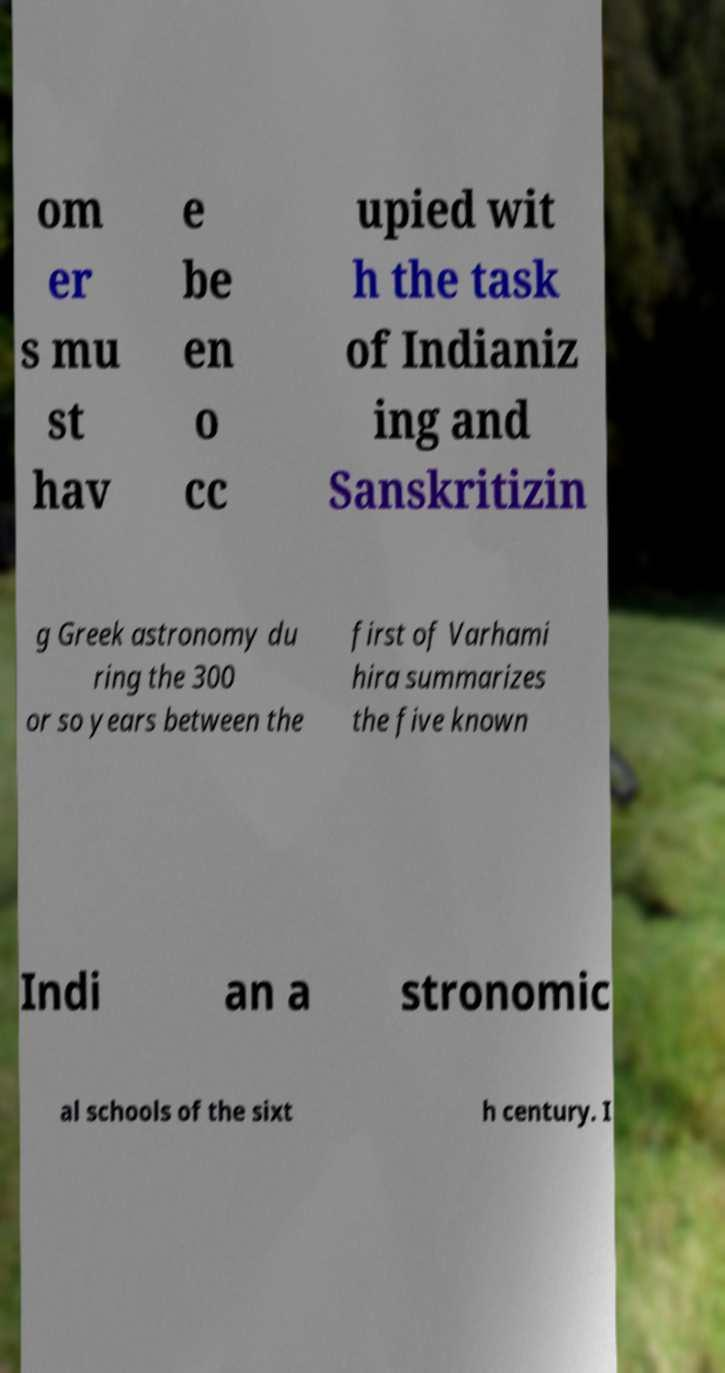Could you assist in decoding the text presented in this image and type it out clearly? om er s mu st hav e be en o cc upied wit h the task of Indianiz ing and Sanskritizin g Greek astronomy du ring the 300 or so years between the first of Varhami hira summarizes the five known Indi an a stronomic al schools of the sixt h century. I 